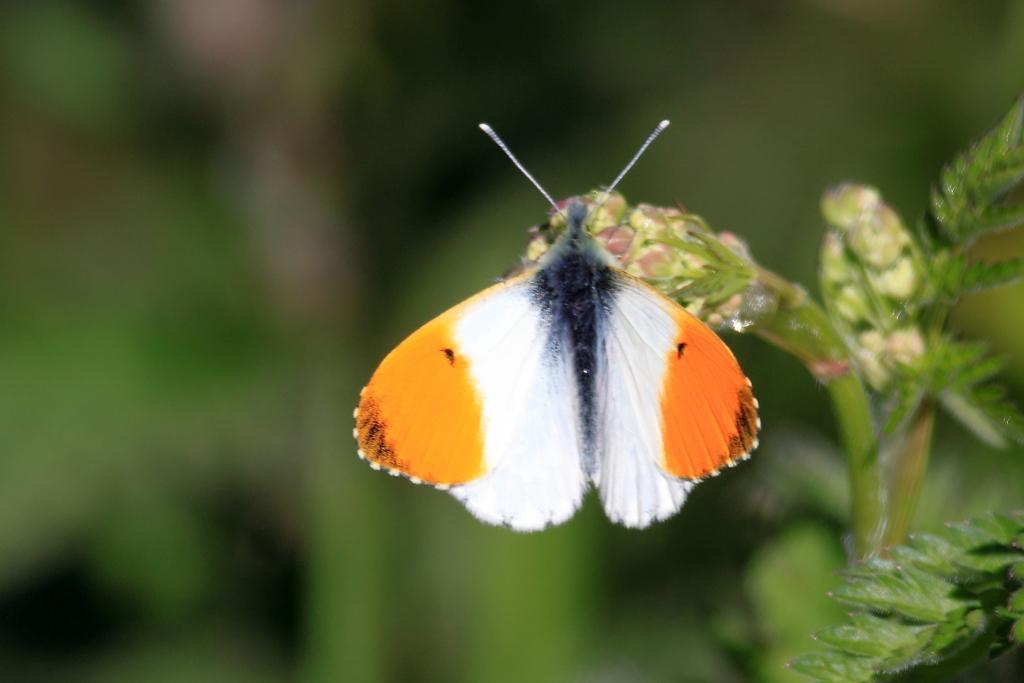How would you summarize this image in a sentence or two? In this picture we see a butterfly on a plant 